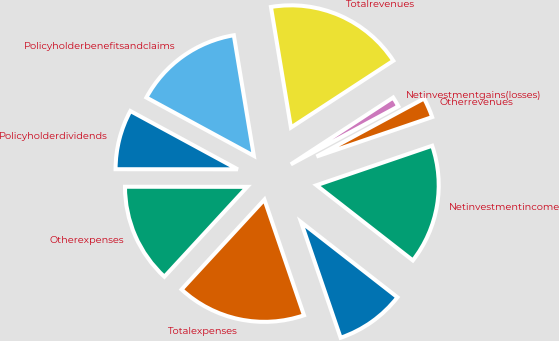Convert chart to OTSL. <chart><loc_0><loc_0><loc_500><loc_500><pie_chart><ecel><fcel>Netinvestmentincome<fcel>Otherrevenues<fcel>Netinvestmentgains(losses)<fcel>Totalrevenues<fcel>Policyholderbenefitsandclaims<fcel>Policyholderdividends<fcel>Otherexpenses<fcel>Totalexpenses<nl><fcel>9.21%<fcel>15.78%<fcel>2.64%<fcel>1.33%<fcel>18.41%<fcel>14.47%<fcel>7.9%<fcel>13.16%<fcel>17.1%<nl></chart> 